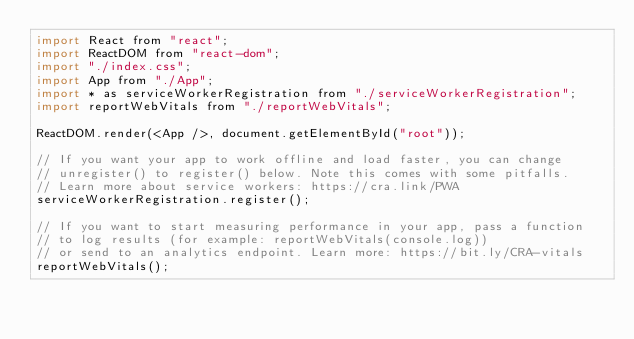<code> <loc_0><loc_0><loc_500><loc_500><_JavaScript_>import React from "react";
import ReactDOM from "react-dom";
import "./index.css";
import App from "./App";
import * as serviceWorkerRegistration from "./serviceWorkerRegistration";
import reportWebVitals from "./reportWebVitals";

ReactDOM.render(<App />, document.getElementById("root"));

// If you want your app to work offline and load faster, you can change
// unregister() to register() below. Note this comes with some pitfalls.
// Learn more about service workers: https://cra.link/PWA
serviceWorkerRegistration.register();

// If you want to start measuring performance in your app, pass a function
// to log results (for example: reportWebVitals(console.log))
// or send to an analytics endpoint. Learn more: https://bit.ly/CRA-vitals
reportWebVitals();
</code> 